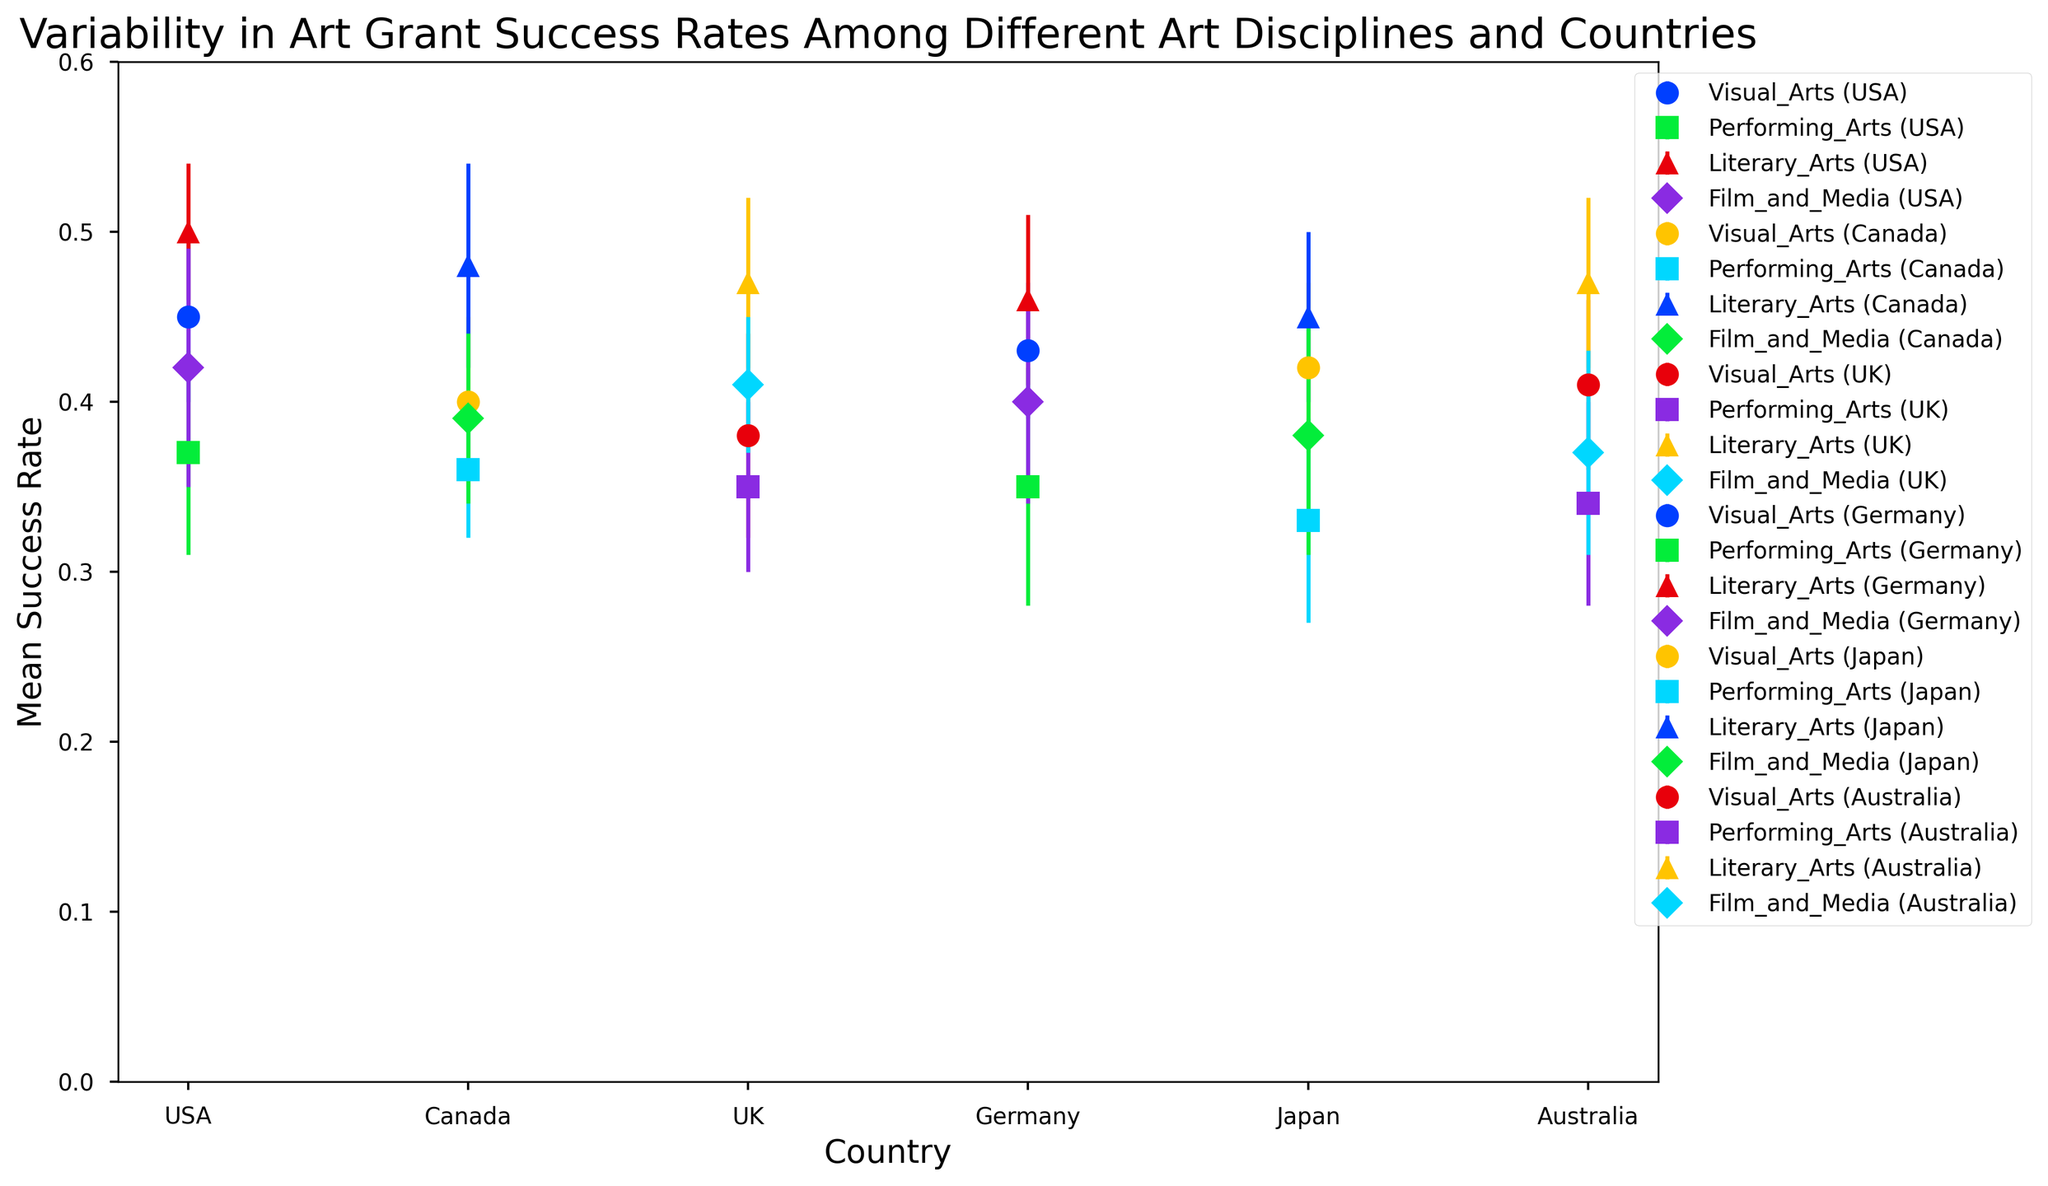Which country has the highest mean success rate for Literary Arts? By looking at the data points for each country under the Literary Arts category, we see that the USA has the highest mean success rate at 0.50.
Answer: USA Which art discipline in Japan shows the greatest variability in success rates? Variability is represented by the standard deviation. By comparing the standard deviations for each art discipline in Japan, Film_and_Media has the highest standard deviation of 0.07.
Answer: Film_and_Media How does the mean success rate for Performing Arts in Germany compare to that in the USA? The mean success rate for Performing Arts in Germany is 0.35 and in the USA is 0.37. Therefore, the USA has a slightly higher success rate for this discipline.
Answer: The USA is higher What is the average mean success rate for Visual Arts across all countries? The mean success rates for Visual Arts are: USA (0.45), Canada (0.40), UK (0.38), Germany (0.43), Japan (0.42), and Australia (0.41). Adding these gives 0.45 + 0.40 + 0.38 + 0.43 + 0.42 + 0.41 = 2.49. Dividing by 6 (number of countries) gives 2.49 / 6 ≈ 0.415.
Answer: 0.415 Which country has the smallest variability overall in Film and Media grant success rates? By comparing the standard deviations for Film_and_Media across all countries, the UK has the smallest standard deviation of 0.04.
Answer: UK Among the listed countries, which one shows the highest variability in Performing Arts success rates? The highest variability is marked by the highest standard deviation. For Performing Arts, Germany has the highest standard deviation of 0.07.
Answer: Germany How does the mean success rate for Visual Arts compare between Canada and the UK? The mean success rate for Visual Arts in Canada is 0.40 and in the UK 0.38. Therefore, Canada has a higher success rate for this discipline compared to the UK.
Answer: Canada is higher What is the difference in mean success rate for Literary Arts between Australia and Germany? Australia's mean success rate for Literary Arts is 0.47 and Germany's is 0.46. The difference is 0.47 - 0.46 = 0.01.
Answer: 0.01 Which art discipline has the overall lowest mean success rate across all countries? By examining the mean success rates for each art discipline across all countries, Performing Arts has the overall lowest mean success rates varying from 0.33 to 0.37.
Answer: Performing Arts What is the combined mean success rate for Literary Arts and Film and Media in Japan? The mean success rate for Literary Arts in Japan is 0.45 and for Film and Media is 0.38. The combined mean success rate is 0.45 + 0.38 = 0.83.
Answer: 0.83 